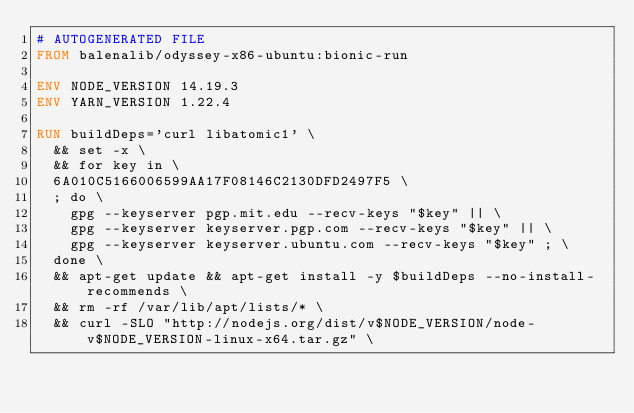<code> <loc_0><loc_0><loc_500><loc_500><_Dockerfile_># AUTOGENERATED FILE
FROM balenalib/odyssey-x86-ubuntu:bionic-run

ENV NODE_VERSION 14.19.3
ENV YARN_VERSION 1.22.4

RUN buildDeps='curl libatomic1' \
	&& set -x \
	&& for key in \
	6A010C5166006599AA17F08146C2130DFD2497F5 \
	; do \
		gpg --keyserver pgp.mit.edu --recv-keys "$key" || \
		gpg --keyserver keyserver.pgp.com --recv-keys "$key" || \
		gpg --keyserver keyserver.ubuntu.com --recv-keys "$key" ; \
	done \
	&& apt-get update && apt-get install -y $buildDeps --no-install-recommends \
	&& rm -rf /var/lib/apt/lists/* \
	&& curl -SLO "http://nodejs.org/dist/v$NODE_VERSION/node-v$NODE_VERSION-linux-x64.tar.gz" \</code> 